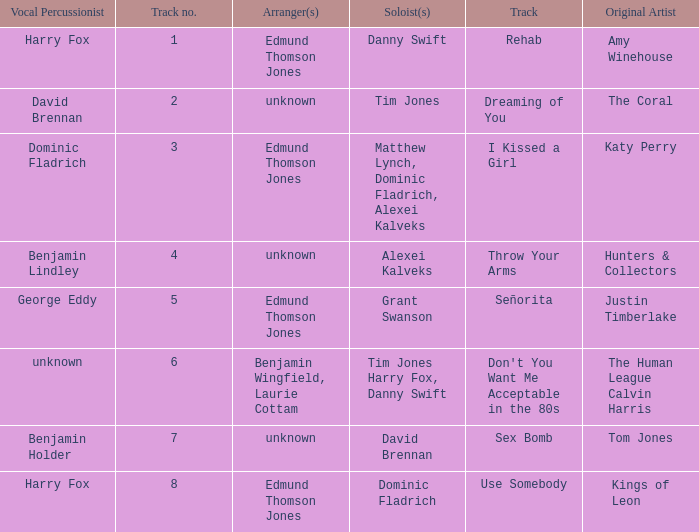Who is the artist where the vocal percussionist is Benjamin Holder? Tom Jones. 